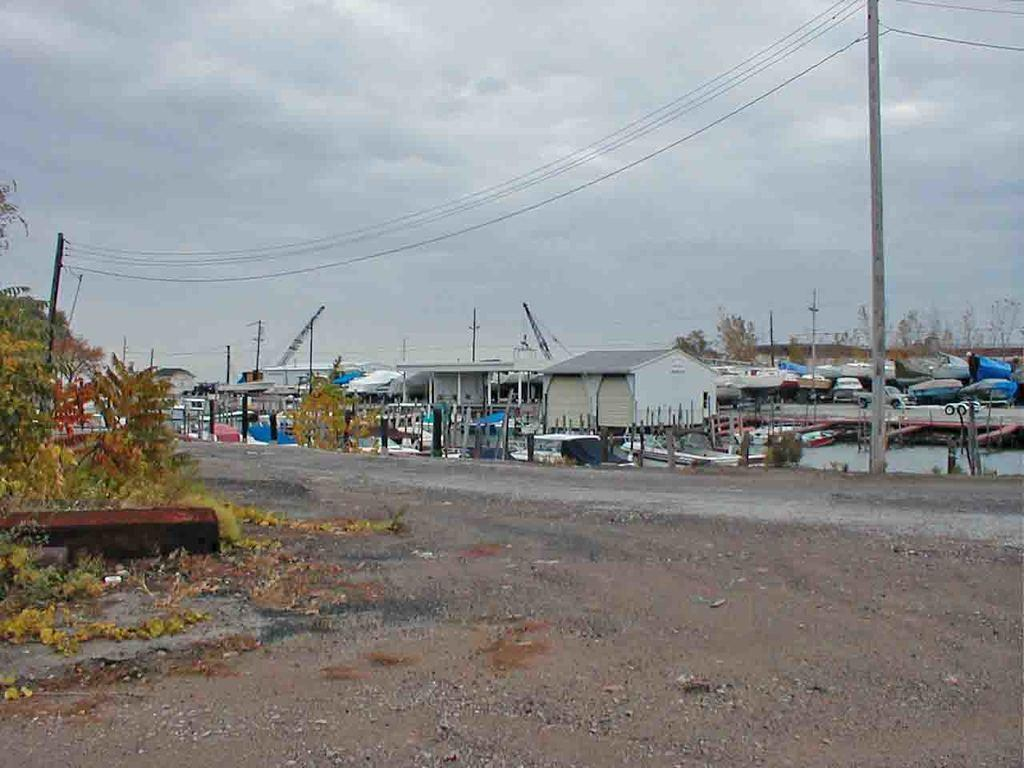What is located in the center of the image? There are houses, poles, and wires in the center of the image. What can be seen at the bottom of the image? Grass, sand, and plants are visible at the bottom of the image. What is visible at the top of the image? The sky is visible at the top of the image. Can you describe the girl playing with the plants in the image? There is no girl or any play activity involving plants present in the image. 